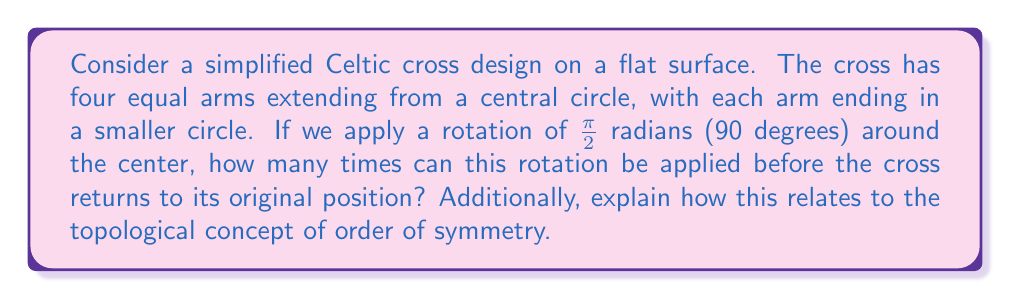Can you answer this question? To analyze the symmetry of this Celtic cross design using topological transformations, we need to consider the rotational symmetry of the shape.

1) First, let's visualize the cross:

[asy]
unitsize(1cm);
draw(circle((0,0),1));
draw((-3,0)--(3,0));
draw((0,-3)--(0,3));
draw(circle((-3,0),0.5));
draw(circle((3,0),0.5));
draw(circle((0,-3),0.5));
draw(circle((0,3),0.5));
[/asy]

2) The rotation we're considering is $\frac{\pi}{2}$ radians or 90 degrees around the center point.

3) Let's apply this rotation step by step:
   - Original position (0 rotations)
   - After 1 rotation of $\frac{\pi}{2}$: The cross looks the same
   - After 2 rotations ($\pi$ radians or 180 degrees): The cross looks the same
   - After 3 rotations ($\frac{3\pi}{2}$ radians or 270 degrees): The cross looks the same
   - After 4 rotations ($2\pi$ radians or 360 degrees): The cross returns to its original position

4) Therefore, the cross can undergo this rotation 4 times before returning to its original position.

5) In terms of topological transformations, this relates to the concept of order of symmetry. The order of symmetry is the number of distinct symmetries a shape possesses.

6) In this case, the rotational order of symmetry is 4, because there are 4 distinct rotational positions (including the original position) before the shape repeats.

7) This symmetry is preserved under continuous deformations that don't break or create new intersections, which is a key principle in topology.
Answer: The Celtic cross can be rotated $\frac{\pi}{2}$ radians 4 times before returning to its original position. The order of rotational symmetry is 4. 